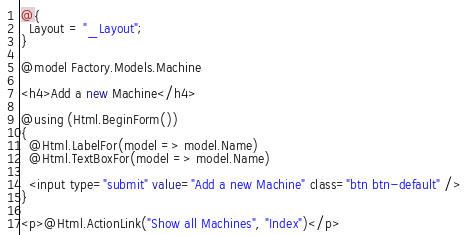<code> <loc_0><loc_0><loc_500><loc_500><_C#_>@{
  Layout = "_Layout";
}

@model Factory.Models.Machine

<h4>Add a new Machine</h4>

@using (Html.BeginForm())
{
  @Html.LabelFor(model => model.Name)
  @Html.TextBoxFor(model => model.Name)

  <input type="submit" value="Add a new Machine" class="btn btn-default" />
}

<p>@Html.ActionLink("Show all Machines", "Index")</p></code> 